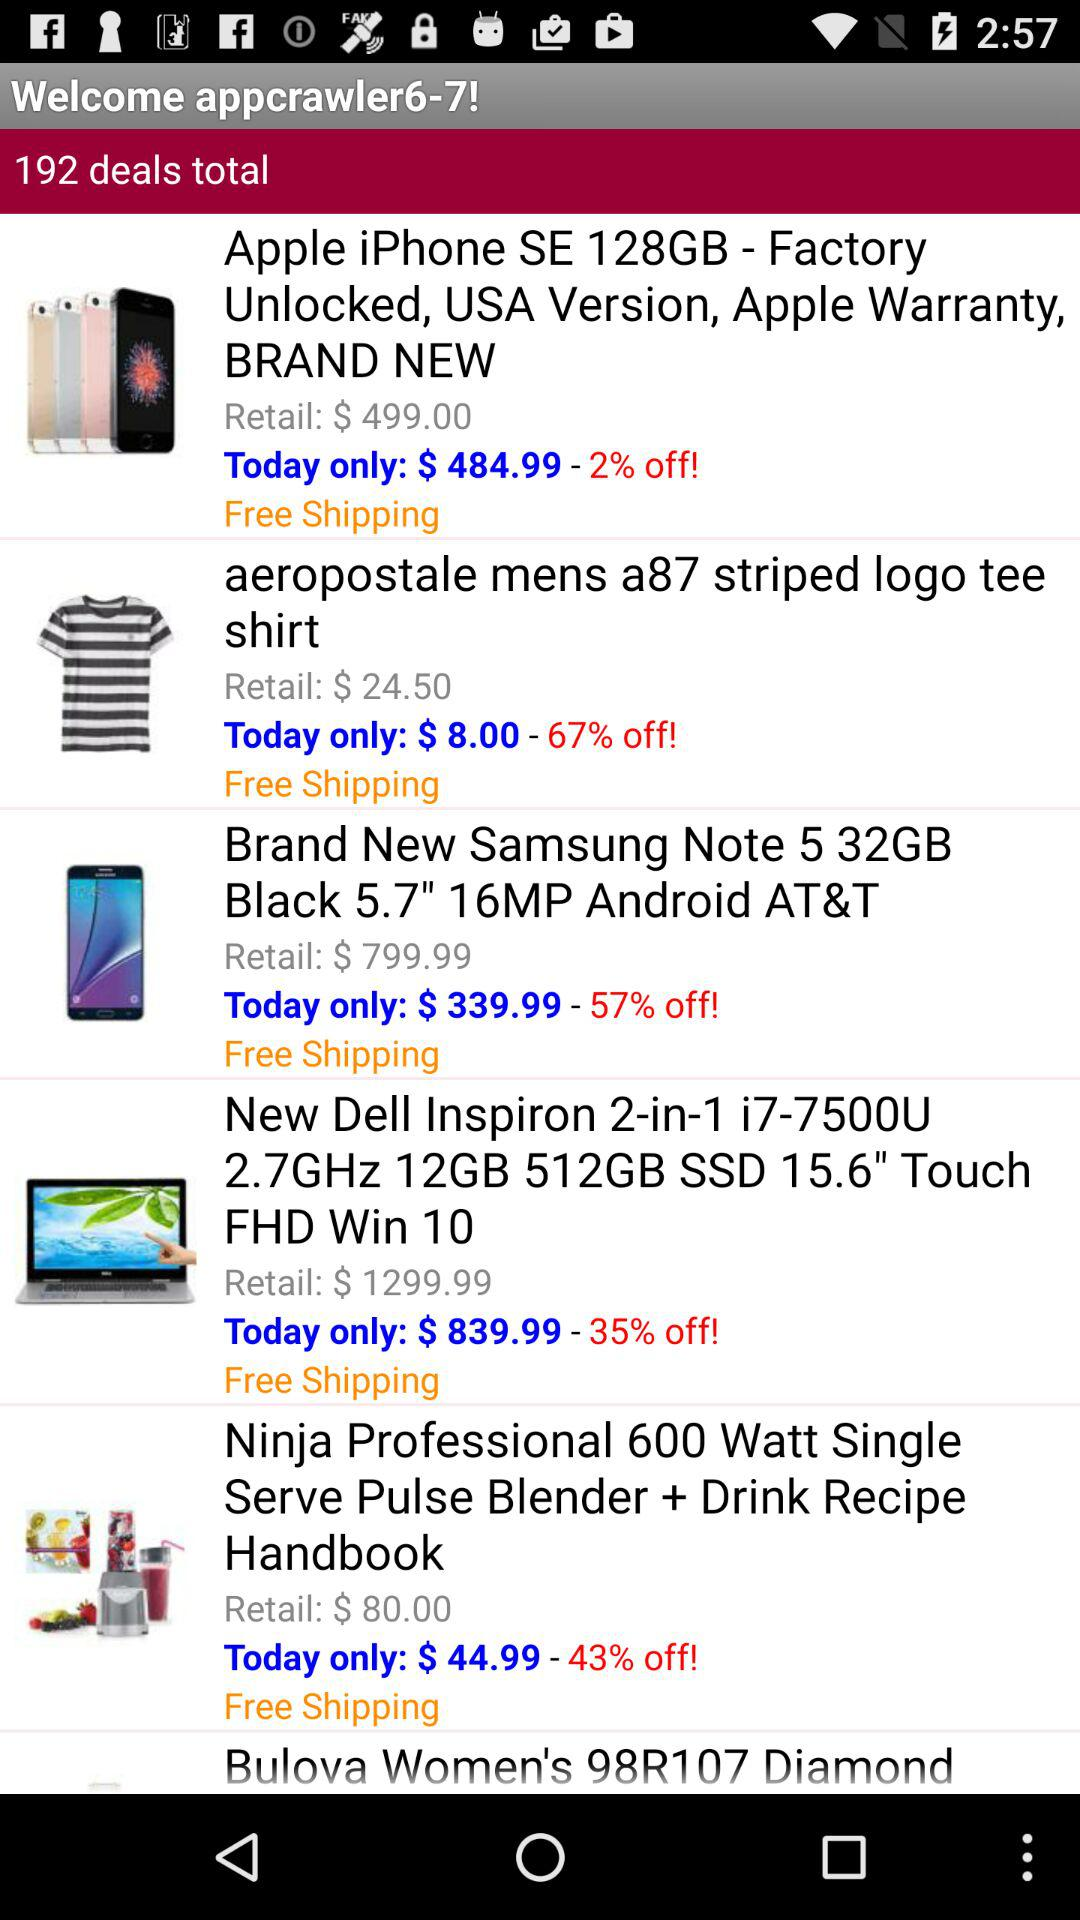How much is the discount on the "aeropostale mens a87 striped logo tee shirt"? The discount on the "aeropostale mens a87 striped logo tee shirt" is 67%. 